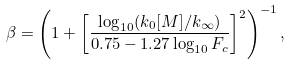<formula> <loc_0><loc_0><loc_500><loc_500>\beta = \left ( 1 + \left [ \frac { \log _ { 1 0 } ( k _ { 0 } [ M ] / k _ { \infty } ) } { 0 . 7 5 - 1 . 2 7 \log _ { 1 0 } F _ { c } } \right ] ^ { 2 } \right ) ^ { - 1 } ,</formula> 